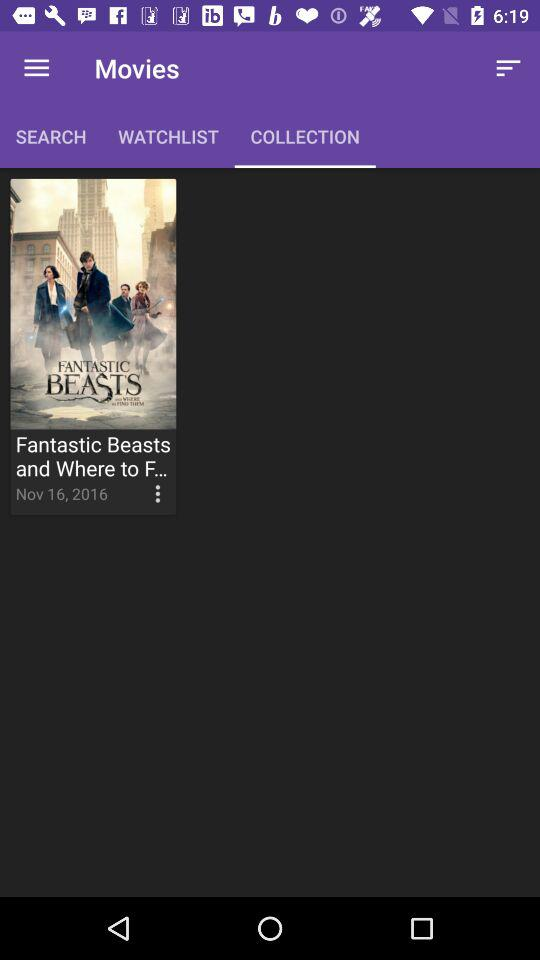What tab is selected? The selected tab is "COLLECTION". 